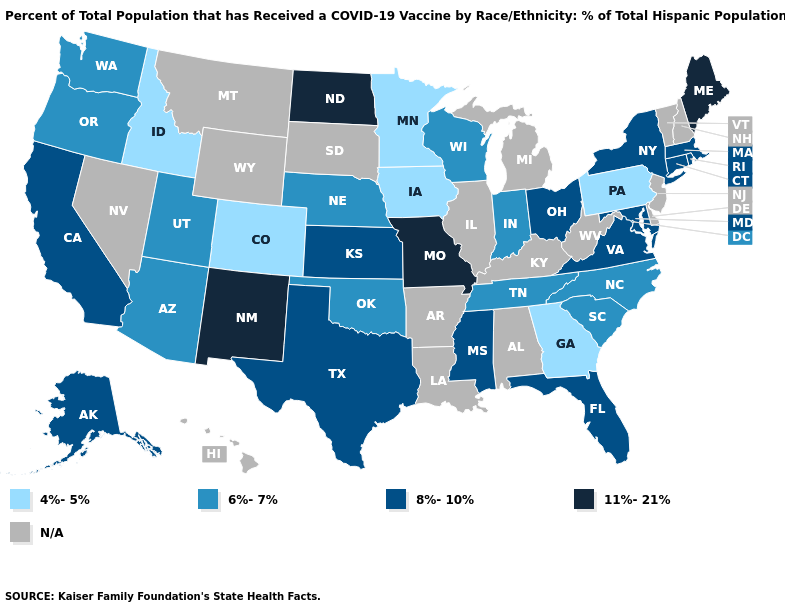Among the states that border Alabama , does Georgia have the highest value?
Give a very brief answer. No. Which states have the highest value in the USA?
Answer briefly. Maine, Missouri, New Mexico, North Dakota. What is the value of North Dakota?
Short answer required. 11%-21%. Is the legend a continuous bar?
Short answer required. No. Does Nebraska have the lowest value in the MidWest?
Be succinct. No. Name the states that have a value in the range 8%-10%?
Quick response, please. Alaska, California, Connecticut, Florida, Kansas, Maryland, Massachusetts, Mississippi, New York, Ohio, Rhode Island, Texas, Virginia. Name the states that have a value in the range 8%-10%?
Quick response, please. Alaska, California, Connecticut, Florida, Kansas, Maryland, Massachusetts, Mississippi, New York, Ohio, Rhode Island, Texas, Virginia. Which states have the lowest value in the USA?
Write a very short answer. Colorado, Georgia, Idaho, Iowa, Minnesota, Pennsylvania. Does the first symbol in the legend represent the smallest category?
Be succinct. Yes. What is the highest value in the USA?
Quick response, please. 11%-21%. What is the value of Washington?
Write a very short answer. 6%-7%. What is the value of New Jersey?
Be succinct. N/A. What is the value of North Carolina?
Concise answer only. 6%-7%. Among the states that border Utah , does New Mexico have the highest value?
Be succinct. Yes. 